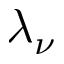<formula> <loc_0><loc_0><loc_500><loc_500>\lambda _ { \nu }</formula> 